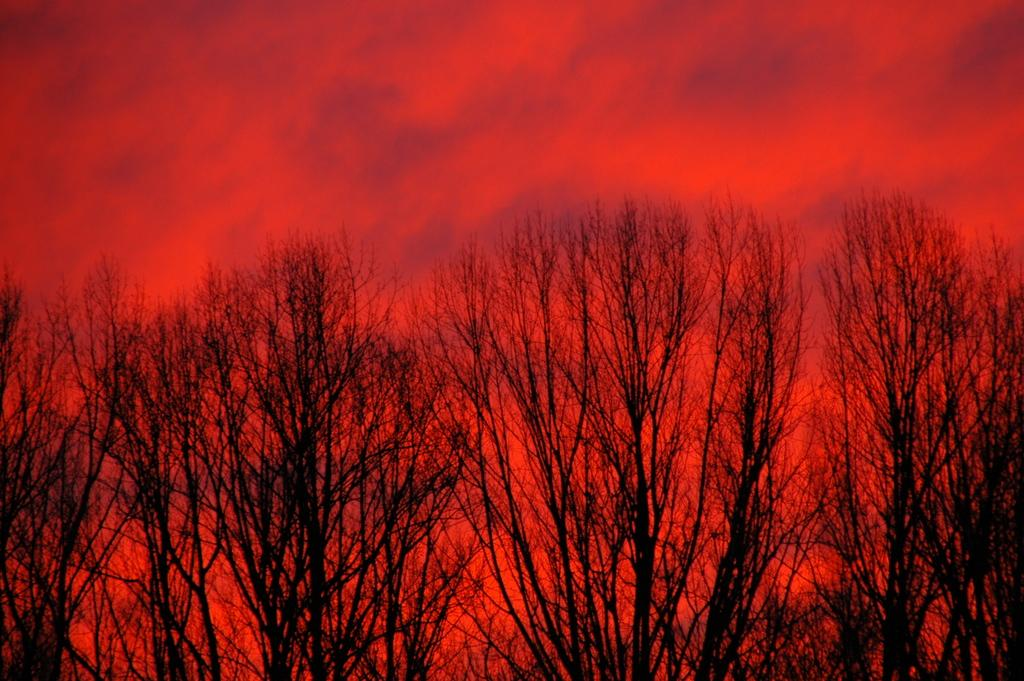What type of vegetation can be seen in the image? There are trees in the image. Where are the trees located in relation to the image? The trees are in the foreground of the image. What can be seen in the background of the image? The sky is visible in the background of the image. What colors are present in the sky? The sky has a red and black color. Can you hear the sound of a whistle in the image? There is no sound present in the image, so it is not possible to hear a whistle. 